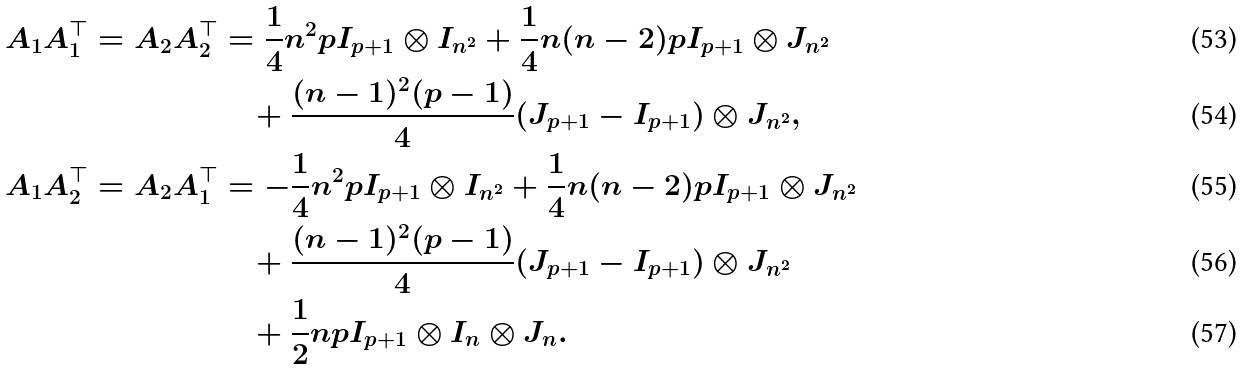Convert formula to latex. <formula><loc_0><loc_0><loc_500><loc_500>A _ { 1 } A _ { 1 } ^ { \top } = A _ { 2 } A _ { 2 } ^ { \top } & = \frac { 1 } { 4 } n ^ { 2 } p I _ { p + 1 } \otimes I _ { n ^ { 2 } } + \frac { 1 } { 4 } n ( n - 2 ) p I _ { p + 1 } \otimes J _ { n ^ { 2 } } \\ & \quad + \frac { ( n - 1 ) ^ { 2 } ( p - 1 ) } { 4 } ( J _ { p + 1 } - I _ { p + 1 } ) \otimes J _ { n ^ { 2 } } , \\ A _ { 1 } A _ { 2 } ^ { \top } = A _ { 2 } A _ { 1 } ^ { \top } & = - \frac { 1 } { 4 } n ^ { 2 } p I _ { p + 1 } \otimes I _ { n ^ { 2 } } + \frac { 1 } { 4 } n ( n - 2 ) p I _ { p + 1 } \otimes J _ { n ^ { 2 } } \\ & \quad + \frac { ( n - 1 ) ^ { 2 } ( p - 1 ) } { 4 } ( J _ { p + 1 } - I _ { p + 1 } ) \otimes J _ { n ^ { 2 } } \\ & \quad + \frac { 1 } { 2 } n p I _ { p + 1 } \otimes I _ { n } \otimes J _ { n } .</formula> 